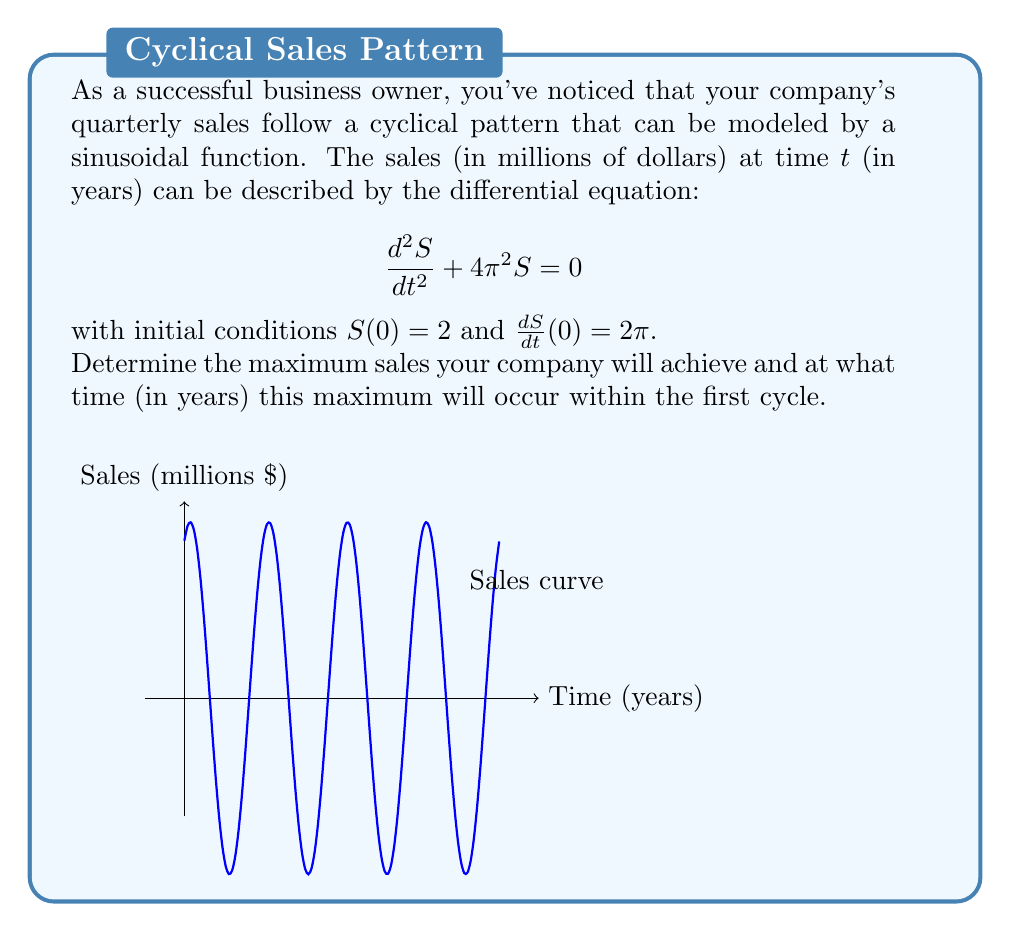Could you help me with this problem? Let's approach this step-by-step:

1) The general solution to the given differential equation is:
   $$S(t) = A\cos(2\pi t) + B\sin(2\pi t)$$

2) Using the initial conditions:
   $S(0) = 2$, so $A = 2$
   $\frac{dS}{dt}(0) = 2\pi$, so $2\pi B = 2\pi$, therefore $B = 1$

3) Thus, our specific solution is:
   $$S(t) = 2\cos(2\pi t) + \sin(2\pi t)$$

4) To find the maximum, we need to find where $\frac{dS}{dt} = 0$:
   $$\frac{dS}{dt} = -4\pi\sin(2\pi t) + 2\pi\cos(2\pi t) = 0$$

5) Dividing by $2\pi$:
   $$-2\sin(2\pi t) + \cos(2\pi t) = 0$$
   $$\tan(2\pi t) = \frac{1}{2}$$

6) Solving this:
   $$2\pi t = \arctan(\frac{1}{2}) + 2\pi n, \quad n = 0,1,2,...$$
   $$t = \frac{1}{2\pi}\arctan(\frac{1}{2}) + n, \quad n = 0,1,2,...$$

7) The first maximum occurs when $n = 0$:
   $$t_{max} = \frac{1}{2\pi}\arctan(\frac{1}{2}) \approx 0.0796 \text{ years}$$

8) The maximum sales value is:
   $$S_{max} = S(t_{max}) = 2\cos(2\pi t_{max}) + \sin(2\pi t_{max})$$
   $$= 2\cos(\arctan(\frac{1}{2})) + \sin(\arctan(\frac{1}{2}))$$
   $$= 2 \cdot \frac{2}{\sqrt{5}} + \frac{1}{\sqrt{5}} = \frac{5}{\sqrt{5}} \approx 2.236 \text{ million dollars}$$
Answer: Maximum sales: $\frac{5}{\sqrt{5}}$ million dollars, occurring at $t = \frac{1}{2\pi}\arctan(\frac{1}{2})$ years. 